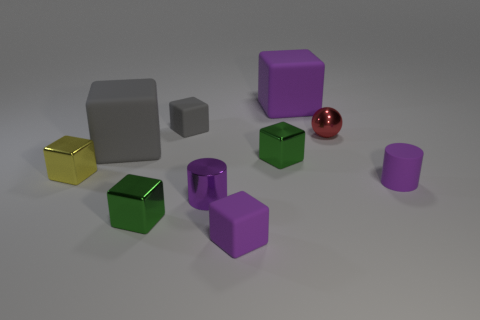Subtract all yellow metal cubes. How many cubes are left? 6 Subtract all cylinders. How many objects are left? 8 Subtract all tiny cylinders. Subtract all big purple blocks. How many objects are left? 7 Add 9 large gray rubber cubes. How many large gray rubber cubes are left? 10 Add 1 big metal cylinders. How many big metal cylinders exist? 1 Subtract all purple blocks. How many blocks are left? 5 Subtract 0 blue cylinders. How many objects are left? 10 Subtract 2 cylinders. How many cylinders are left? 0 Subtract all green blocks. Subtract all yellow spheres. How many blocks are left? 5 Subtract all brown cylinders. How many blue balls are left? 0 